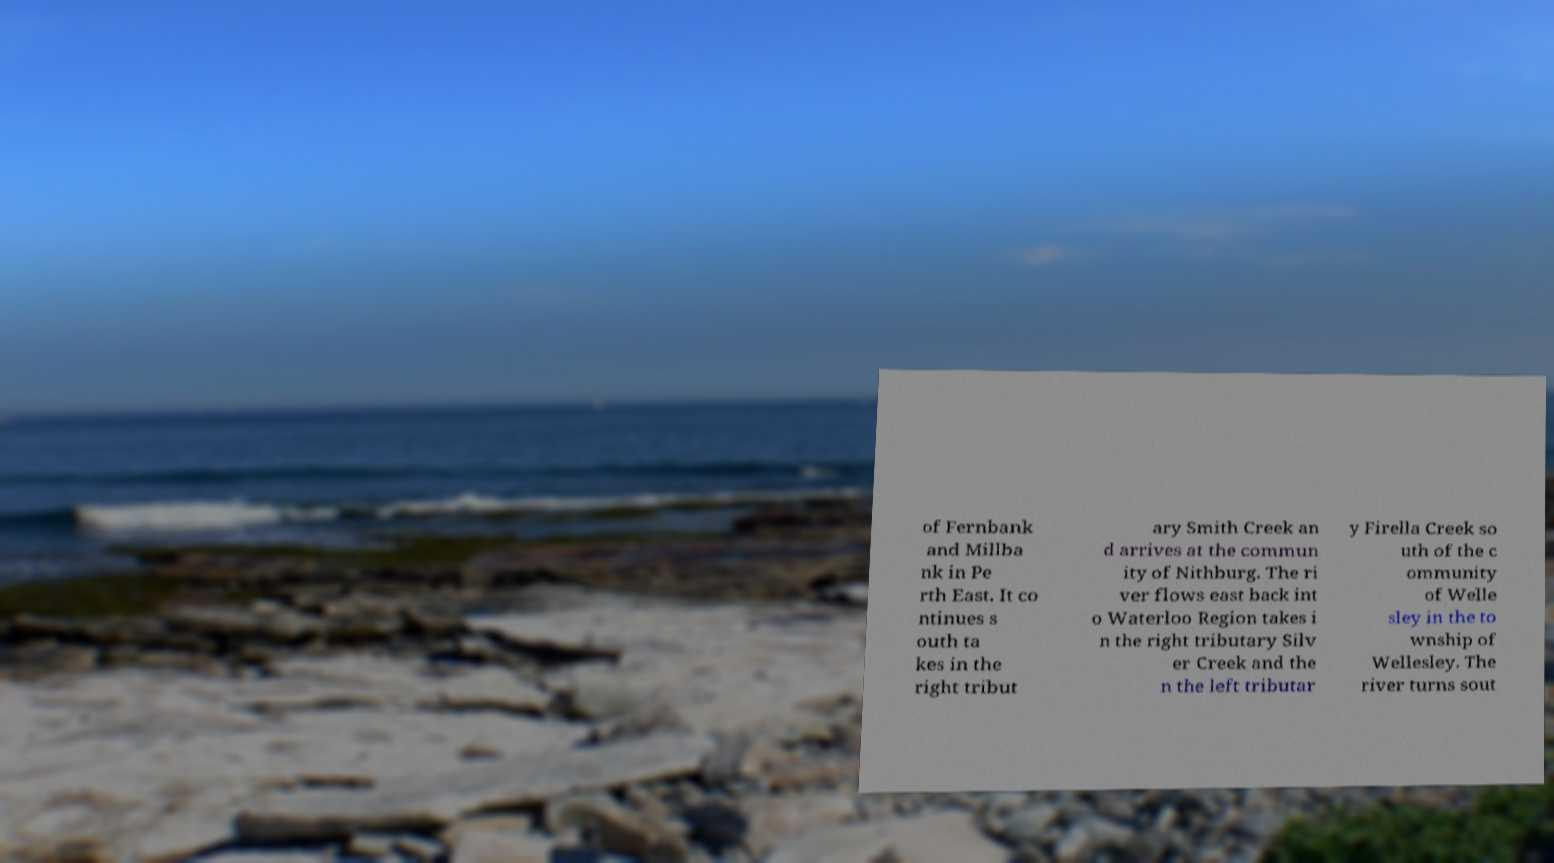Could you assist in decoding the text presented in this image and type it out clearly? of Fernbank and Millba nk in Pe rth East. It co ntinues s outh ta kes in the right tribut ary Smith Creek an d arrives at the commun ity of Nithburg. The ri ver flows east back int o Waterloo Region takes i n the right tributary Silv er Creek and the n the left tributar y Firella Creek so uth of the c ommunity of Welle sley in the to wnship of Wellesley. The river turns sout 